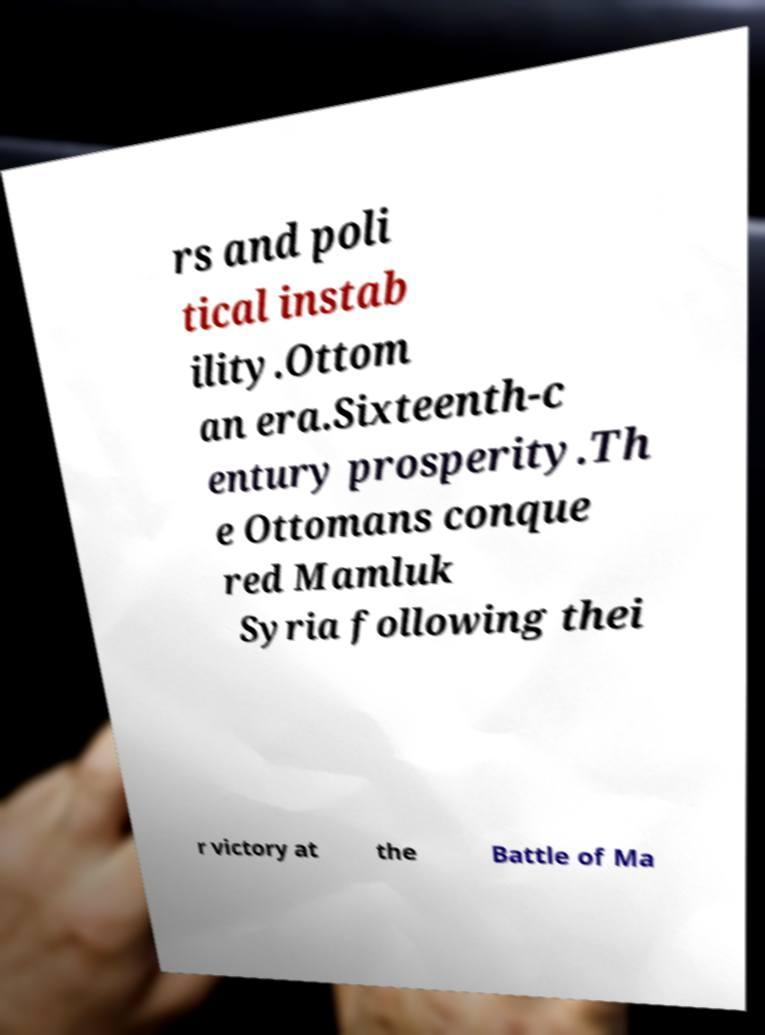Please read and relay the text visible in this image. What does it say? rs and poli tical instab ility.Ottom an era.Sixteenth-c entury prosperity.Th e Ottomans conque red Mamluk Syria following thei r victory at the Battle of Ma 